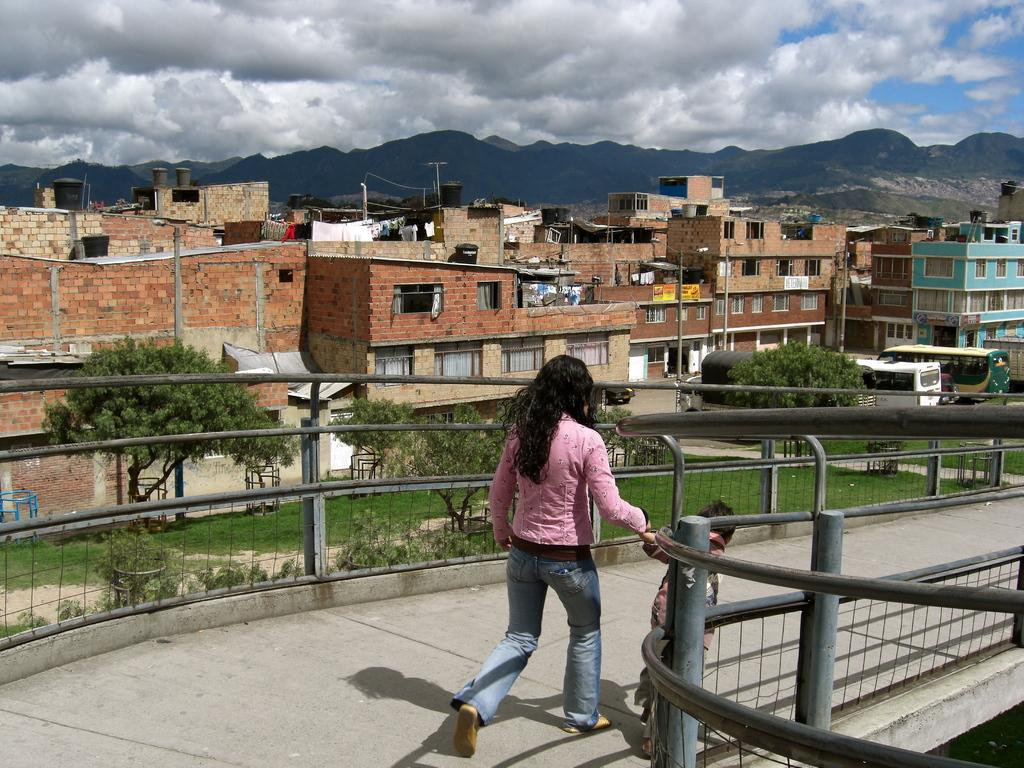Who can be seen in the image? There is a lady and a child in the image. What are they doing in the image? They are walking on a bridge. What can be seen in the background of the image? There are trees, buildings, poles, and vehicles in the background of the image. What is visible at the top of the image? The sky is visible at the top of the image, and there are clouds in the sky. What type of print can be seen on the child's clothing in the image? There is no information about the child's clothing or any print on it in the provided facts. --- Facts: 1. There is a group of people in the image. 2. They are sitting on a bench. 3. There is a table in front of the bench. 4. There are books on the table. 5. There is a plant on the table. 6. The sky is visible at the top of the image. Absurd Topics: animals, ocean, temperature Conversation: How many people are in the image? There is a group of people in the image. What are the people in the image doing? They are sitting on a bench. What is in front of the bench? There is a table in front of the bench. What items can be seen on the table? There are books and a plant on the table. What is visible at the top of the image? The sky is visible at the top of the image. Reasoning: Let's think step by step in order to produce the conversation. We start by identifying the main subject in the image, which is the group of people. Then, we describe their actions, which is sitting on a bench. Next, we expand the conversation to include the table and its contents, such as books and a plant. Finally, we mention the sky visible at the top of the image. Absurd Question/Answer: Can you tell me the temperature of the ocean in the image? There is no ocean present in the image, so it is not possible to determine the temperature. 